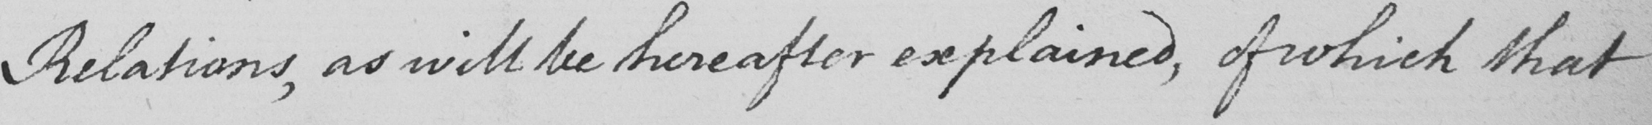What is written in this line of handwriting? Relations , as will be hereafter explained , of which that 